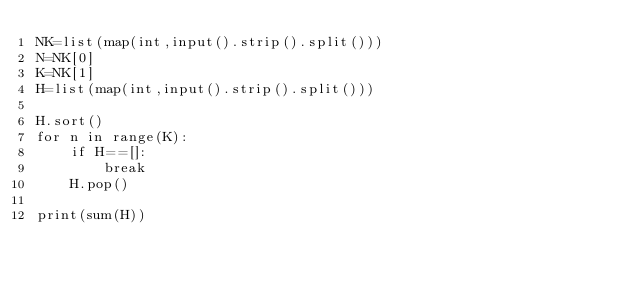<code> <loc_0><loc_0><loc_500><loc_500><_Python_>NK=list(map(int,input().strip().split()))
N=NK[0]
K=NK[1]
H=list(map(int,input().strip().split()))

H.sort()
for n in range(K):
    if H==[]:
        break
    H.pop()

print(sum(H))</code> 